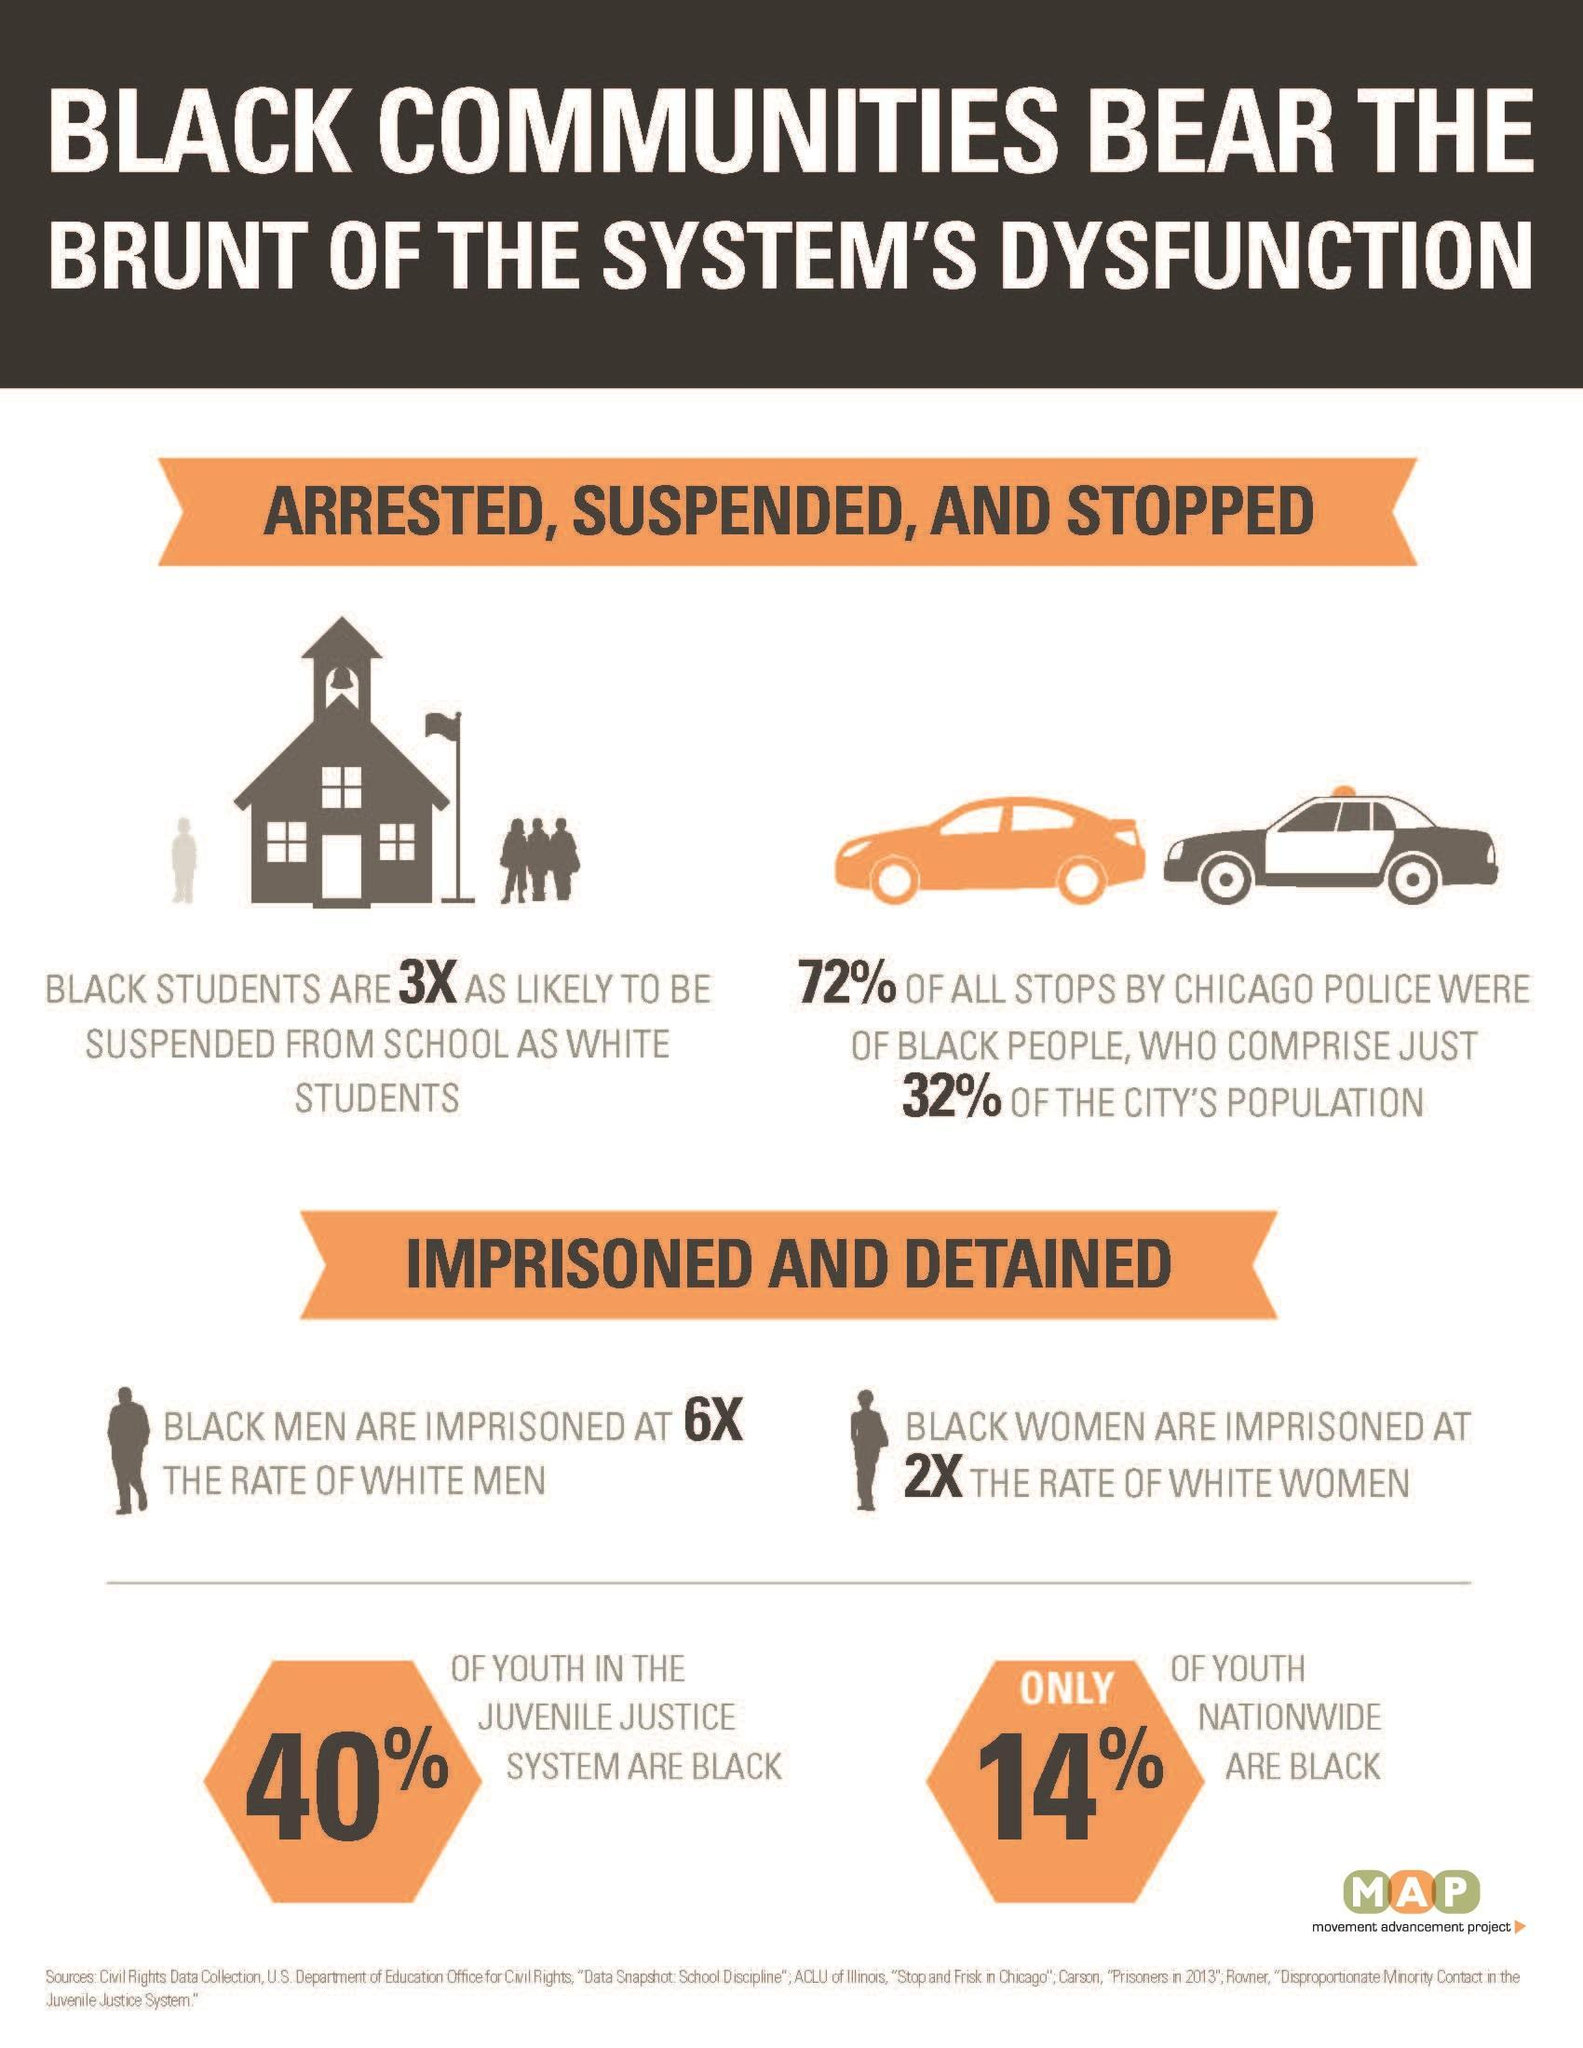What percentage of youth in the juvenile justice system are not black?
Answer the question with a short phrase. 60% What percentage of youth nationwide are blacks? 14% 